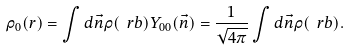Convert formula to latex. <formula><loc_0><loc_0><loc_500><loc_500>\rho _ { 0 } ( r ) = \int d \vec { n } \rho ( \ r b ) Y _ { 0 0 } ( \vec { n } ) = \frac { 1 } { \sqrt { 4 \pi } } \int d \vec { n } \rho ( \ r b ) .</formula> 